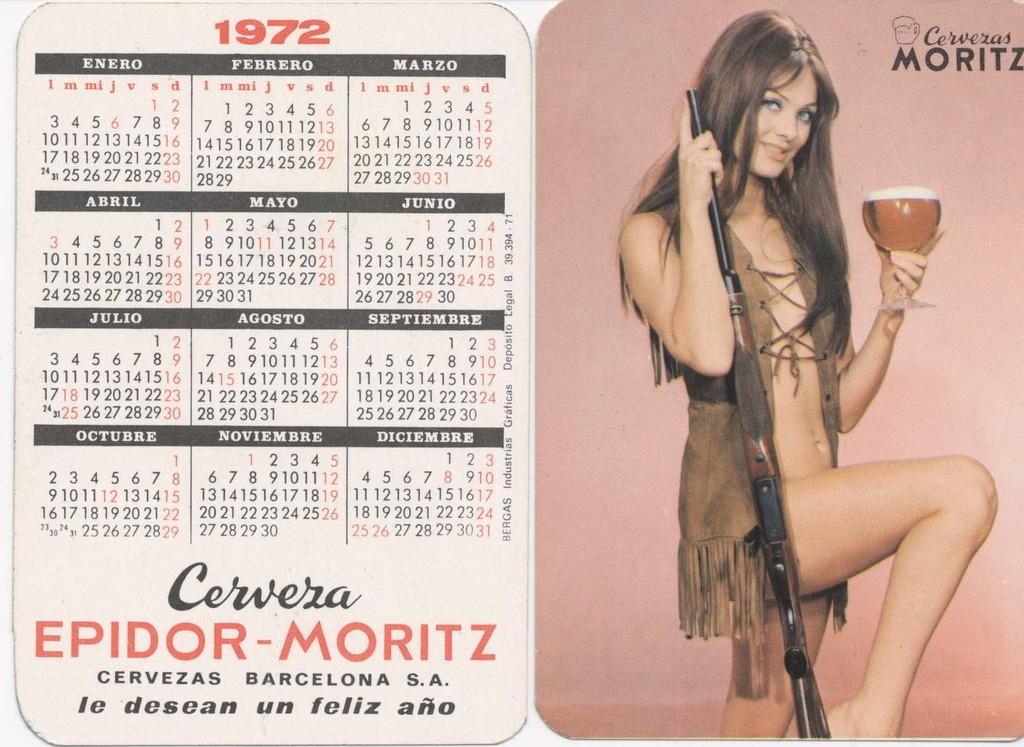What type of image is being described? The image is a collage. What specific item can be found in the collage? There is a calendar in the collage. What is the woman in the collage doing? The woman is holding a gun and a glass in the collage. Where is the text located in the image? The text is on the top right of the image. What type of glue is being used to hold the collage together? There is no information provided about the glue used to create the collage, so it cannot be determined from the image. 